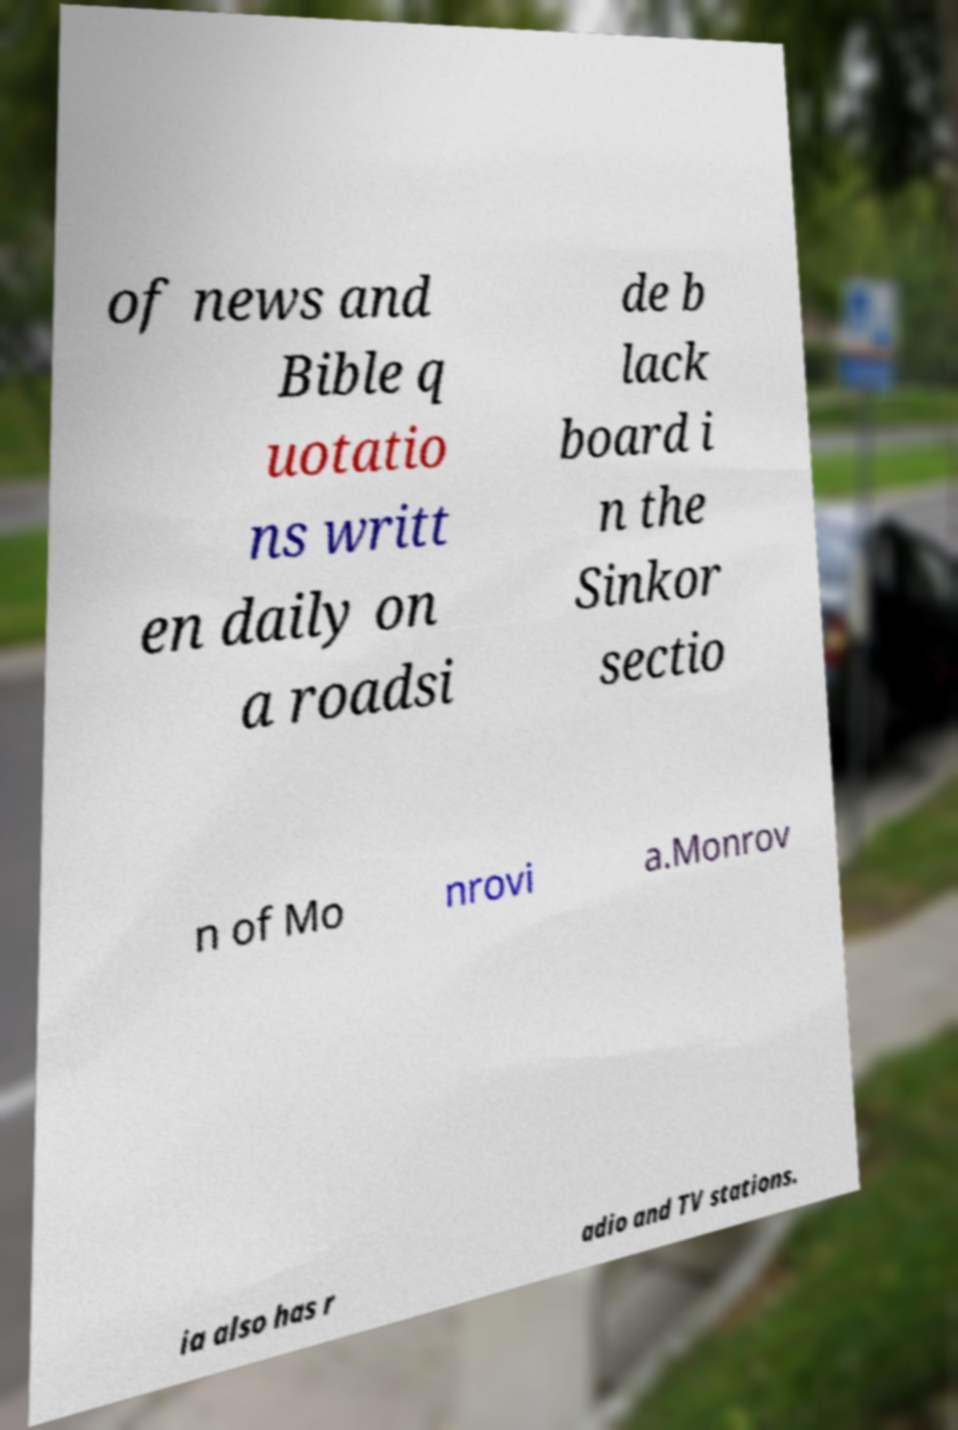Could you extract and type out the text from this image? of news and Bible q uotatio ns writt en daily on a roadsi de b lack board i n the Sinkor sectio n of Mo nrovi a.Monrov ia also has r adio and TV stations. 